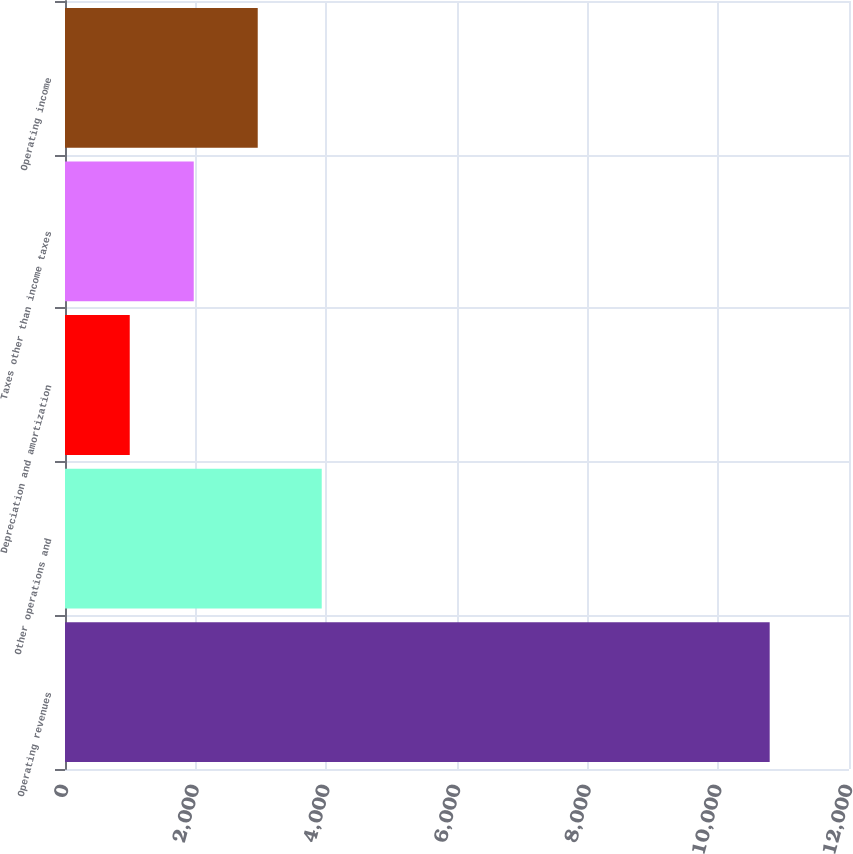Convert chart to OTSL. <chart><loc_0><loc_0><loc_500><loc_500><bar_chart><fcel>Operating revenues<fcel>Other operations and<fcel>Depreciation and amortization<fcel>Taxes other than income taxes<fcel>Operating income<nl><fcel>10786<fcel>3929.5<fcel>991<fcel>1970.5<fcel>2950<nl></chart> 